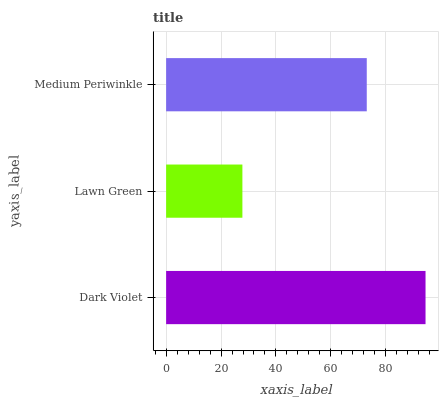Is Lawn Green the minimum?
Answer yes or no. Yes. Is Dark Violet the maximum?
Answer yes or no. Yes. Is Medium Periwinkle the minimum?
Answer yes or no. No. Is Medium Periwinkle the maximum?
Answer yes or no. No. Is Medium Periwinkle greater than Lawn Green?
Answer yes or no. Yes. Is Lawn Green less than Medium Periwinkle?
Answer yes or no. Yes. Is Lawn Green greater than Medium Periwinkle?
Answer yes or no. No. Is Medium Periwinkle less than Lawn Green?
Answer yes or no. No. Is Medium Periwinkle the high median?
Answer yes or no. Yes. Is Medium Periwinkle the low median?
Answer yes or no. Yes. Is Lawn Green the high median?
Answer yes or no. No. Is Dark Violet the low median?
Answer yes or no. No. 